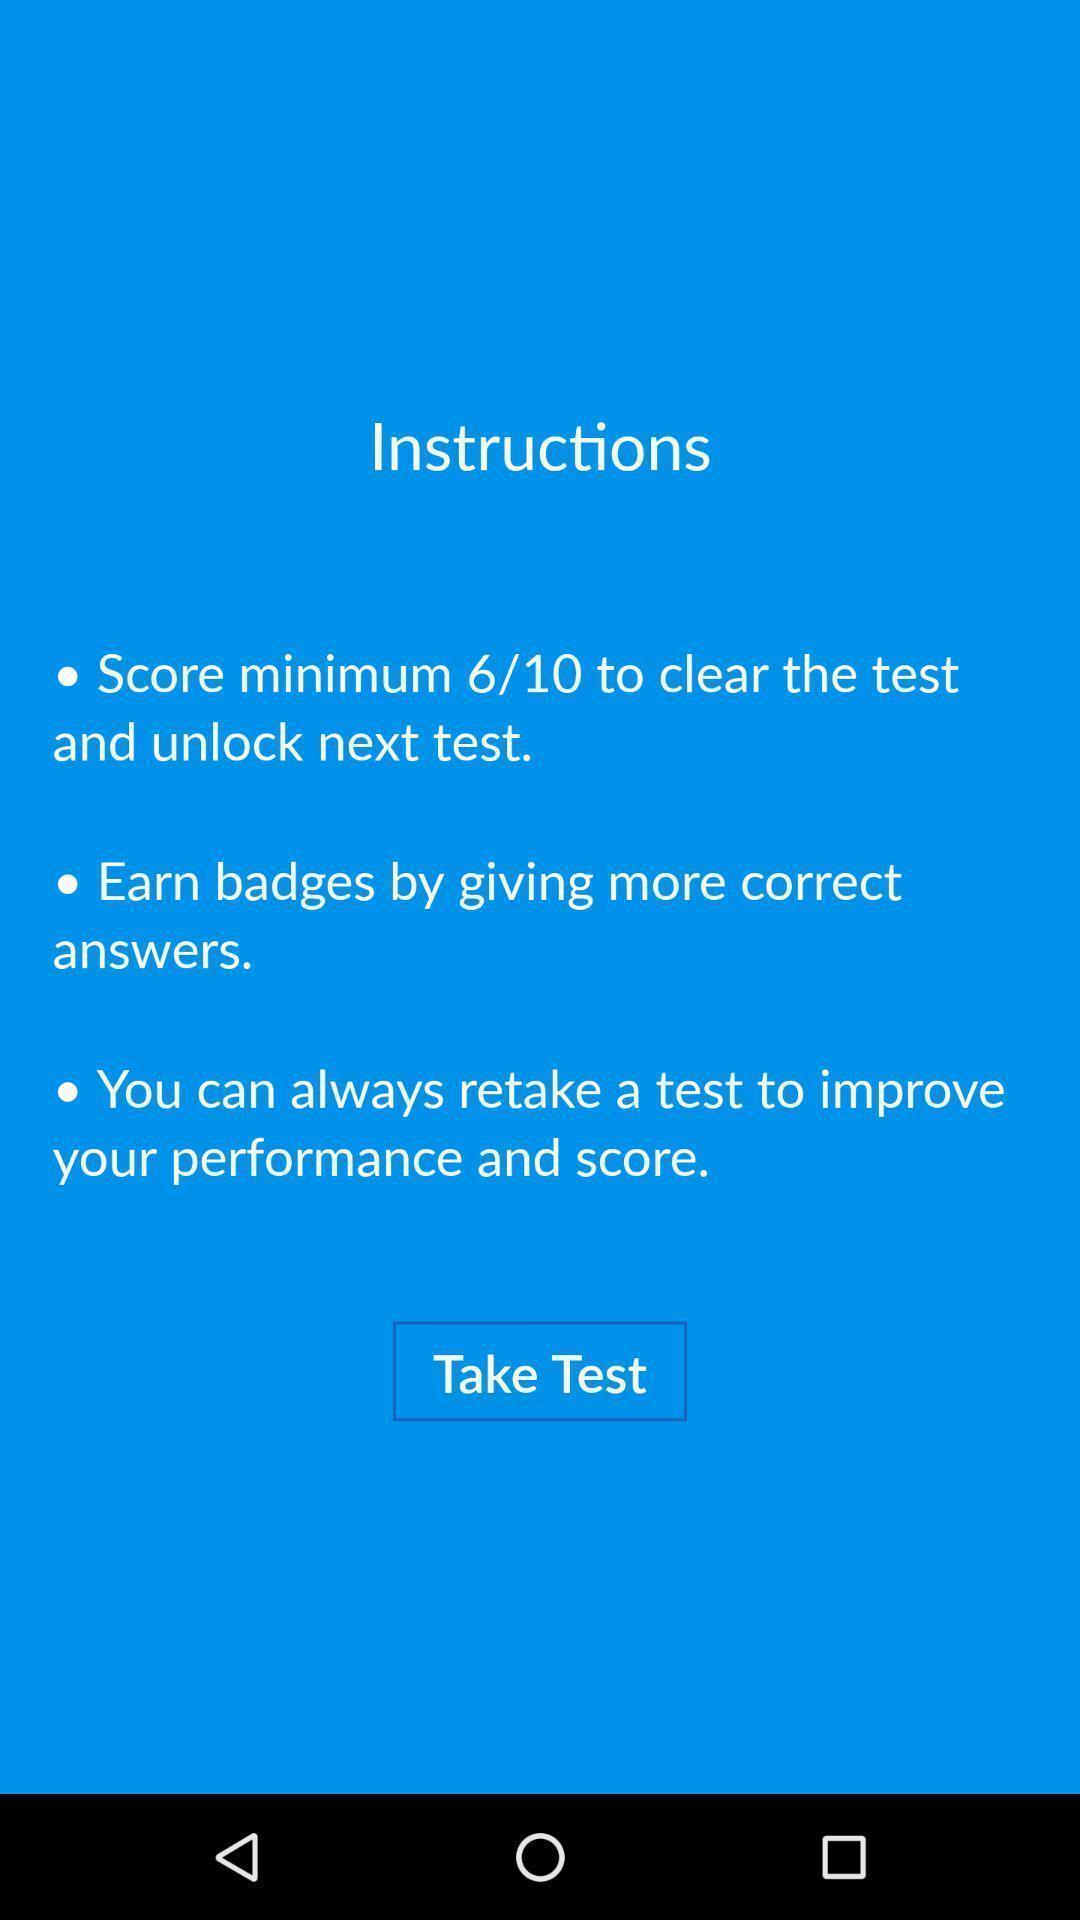Describe the visual elements of this screenshot. Page instructing to take test. 